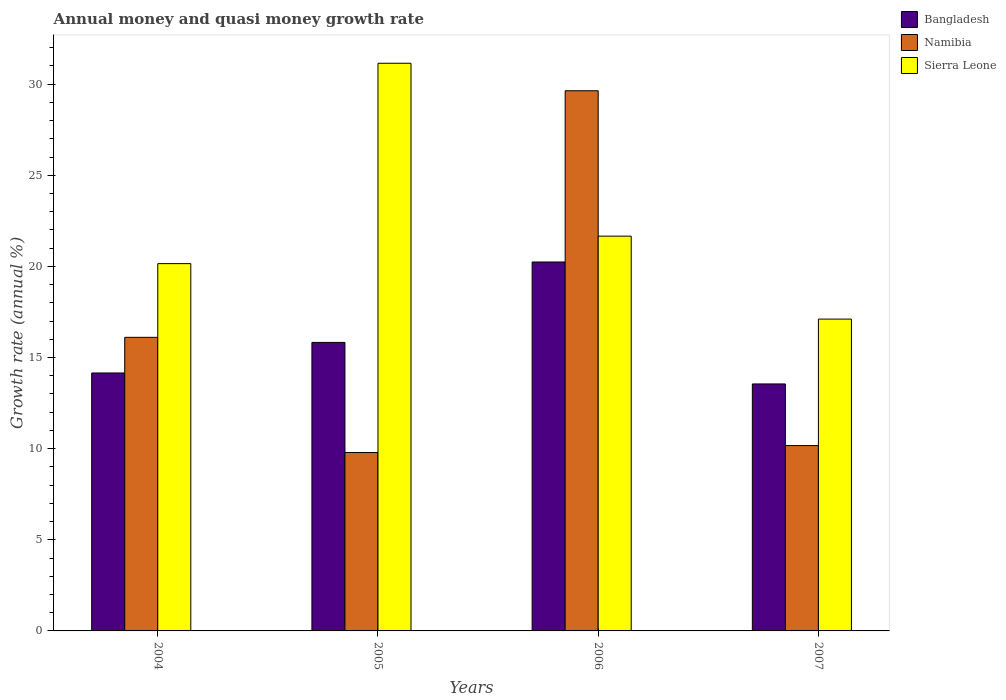What is the label of the 1st group of bars from the left?
Your answer should be very brief. 2004. In how many cases, is the number of bars for a given year not equal to the number of legend labels?
Your answer should be very brief. 0. What is the growth rate in Bangladesh in 2005?
Offer a terse response. 15.83. Across all years, what is the maximum growth rate in Bangladesh?
Your answer should be compact. 20.24. Across all years, what is the minimum growth rate in Sierra Leone?
Provide a succinct answer. 17.11. In which year was the growth rate in Bangladesh maximum?
Offer a terse response. 2006. What is the total growth rate in Bangladesh in the graph?
Offer a very short reply. 63.77. What is the difference between the growth rate in Namibia in 2004 and that in 2007?
Provide a short and direct response. 5.94. What is the difference between the growth rate in Sierra Leone in 2006 and the growth rate in Namibia in 2004?
Your answer should be very brief. 5.55. What is the average growth rate in Bangladesh per year?
Offer a very short reply. 15.94. In the year 2006, what is the difference between the growth rate in Bangladesh and growth rate in Namibia?
Offer a terse response. -9.4. What is the ratio of the growth rate in Namibia in 2005 to that in 2007?
Offer a very short reply. 0.96. Is the growth rate in Namibia in 2004 less than that in 2007?
Provide a short and direct response. No. Is the difference between the growth rate in Bangladesh in 2004 and 2006 greater than the difference between the growth rate in Namibia in 2004 and 2006?
Ensure brevity in your answer.  Yes. What is the difference between the highest and the second highest growth rate in Namibia?
Make the answer very short. 13.53. What is the difference between the highest and the lowest growth rate in Namibia?
Provide a short and direct response. 19.85. In how many years, is the growth rate in Sierra Leone greater than the average growth rate in Sierra Leone taken over all years?
Offer a very short reply. 1. Is the sum of the growth rate in Namibia in 2004 and 2005 greater than the maximum growth rate in Bangladesh across all years?
Offer a terse response. Yes. What does the 1st bar from the left in 2007 represents?
Offer a very short reply. Bangladesh. What does the 3rd bar from the right in 2006 represents?
Provide a short and direct response. Bangladesh. Is it the case that in every year, the sum of the growth rate in Bangladesh and growth rate in Namibia is greater than the growth rate in Sierra Leone?
Keep it short and to the point. No. How many bars are there?
Ensure brevity in your answer.  12. What is the difference between two consecutive major ticks on the Y-axis?
Offer a terse response. 5. Where does the legend appear in the graph?
Make the answer very short. Top right. How many legend labels are there?
Ensure brevity in your answer.  3. What is the title of the graph?
Offer a terse response. Annual money and quasi money growth rate. What is the label or title of the X-axis?
Offer a terse response. Years. What is the label or title of the Y-axis?
Offer a very short reply. Growth rate (annual %). What is the Growth rate (annual %) of Bangladesh in 2004?
Provide a short and direct response. 14.15. What is the Growth rate (annual %) in Namibia in 2004?
Your response must be concise. 16.11. What is the Growth rate (annual %) of Sierra Leone in 2004?
Make the answer very short. 20.15. What is the Growth rate (annual %) of Bangladesh in 2005?
Your response must be concise. 15.83. What is the Growth rate (annual %) in Namibia in 2005?
Provide a succinct answer. 9.79. What is the Growth rate (annual %) of Sierra Leone in 2005?
Your answer should be very brief. 31.15. What is the Growth rate (annual %) of Bangladesh in 2006?
Offer a terse response. 20.24. What is the Growth rate (annual %) of Namibia in 2006?
Offer a terse response. 29.64. What is the Growth rate (annual %) of Sierra Leone in 2006?
Your answer should be compact. 21.66. What is the Growth rate (annual %) in Bangladesh in 2007?
Your response must be concise. 13.55. What is the Growth rate (annual %) of Namibia in 2007?
Your answer should be very brief. 10.17. What is the Growth rate (annual %) in Sierra Leone in 2007?
Keep it short and to the point. 17.11. Across all years, what is the maximum Growth rate (annual %) of Bangladesh?
Your response must be concise. 20.24. Across all years, what is the maximum Growth rate (annual %) of Namibia?
Give a very brief answer. 29.64. Across all years, what is the maximum Growth rate (annual %) of Sierra Leone?
Make the answer very short. 31.15. Across all years, what is the minimum Growth rate (annual %) of Bangladesh?
Provide a short and direct response. 13.55. Across all years, what is the minimum Growth rate (annual %) of Namibia?
Your answer should be compact. 9.79. Across all years, what is the minimum Growth rate (annual %) of Sierra Leone?
Offer a terse response. 17.11. What is the total Growth rate (annual %) of Bangladesh in the graph?
Your answer should be very brief. 63.77. What is the total Growth rate (annual %) of Namibia in the graph?
Ensure brevity in your answer.  65.7. What is the total Growth rate (annual %) of Sierra Leone in the graph?
Your answer should be very brief. 90.07. What is the difference between the Growth rate (annual %) of Bangladesh in 2004 and that in 2005?
Provide a succinct answer. -1.68. What is the difference between the Growth rate (annual %) in Namibia in 2004 and that in 2005?
Offer a terse response. 6.32. What is the difference between the Growth rate (annual %) of Sierra Leone in 2004 and that in 2005?
Your answer should be compact. -10.99. What is the difference between the Growth rate (annual %) of Bangladesh in 2004 and that in 2006?
Keep it short and to the point. -6.09. What is the difference between the Growth rate (annual %) of Namibia in 2004 and that in 2006?
Your response must be concise. -13.53. What is the difference between the Growth rate (annual %) of Sierra Leone in 2004 and that in 2006?
Keep it short and to the point. -1.51. What is the difference between the Growth rate (annual %) in Bangladesh in 2004 and that in 2007?
Provide a succinct answer. 0.6. What is the difference between the Growth rate (annual %) in Namibia in 2004 and that in 2007?
Provide a short and direct response. 5.94. What is the difference between the Growth rate (annual %) in Sierra Leone in 2004 and that in 2007?
Ensure brevity in your answer.  3.04. What is the difference between the Growth rate (annual %) of Bangladesh in 2005 and that in 2006?
Keep it short and to the point. -4.41. What is the difference between the Growth rate (annual %) of Namibia in 2005 and that in 2006?
Make the answer very short. -19.85. What is the difference between the Growth rate (annual %) of Sierra Leone in 2005 and that in 2006?
Offer a very short reply. 9.48. What is the difference between the Growth rate (annual %) in Bangladesh in 2005 and that in 2007?
Ensure brevity in your answer.  2.28. What is the difference between the Growth rate (annual %) in Namibia in 2005 and that in 2007?
Make the answer very short. -0.38. What is the difference between the Growth rate (annual %) of Sierra Leone in 2005 and that in 2007?
Offer a very short reply. 14.04. What is the difference between the Growth rate (annual %) of Bangladesh in 2006 and that in 2007?
Offer a very short reply. 6.69. What is the difference between the Growth rate (annual %) of Namibia in 2006 and that in 2007?
Offer a terse response. 19.47. What is the difference between the Growth rate (annual %) in Sierra Leone in 2006 and that in 2007?
Give a very brief answer. 4.55. What is the difference between the Growth rate (annual %) in Bangladesh in 2004 and the Growth rate (annual %) in Namibia in 2005?
Your response must be concise. 4.36. What is the difference between the Growth rate (annual %) of Bangladesh in 2004 and the Growth rate (annual %) of Sierra Leone in 2005?
Offer a very short reply. -16.99. What is the difference between the Growth rate (annual %) in Namibia in 2004 and the Growth rate (annual %) in Sierra Leone in 2005?
Keep it short and to the point. -15.04. What is the difference between the Growth rate (annual %) in Bangladesh in 2004 and the Growth rate (annual %) in Namibia in 2006?
Offer a very short reply. -15.48. What is the difference between the Growth rate (annual %) of Bangladesh in 2004 and the Growth rate (annual %) of Sierra Leone in 2006?
Offer a terse response. -7.51. What is the difference between the Growth rate (annual %) in Namibia in 2004 and the Growth rate (annual %) in Sierra Leone in 2006?
Offer a terse response. -5.55. What is the difference between the Growth rate (annual %) of Bangladesh in 2004 and the Growth rate (annual %) of Namibia in 2007?
Your response must be concise. 3.98. What is the difference between the Growth rate (annual %) in Bangladesh in 2004 and the Growth rate (annual %) in Sierra Leone in 2007?
Make the answer very short. -2.96. What is the difference between the Growth rate (annual %) in Namibia in 2004 and the Growth rate (annual %) in Sierra Leone in 2007?
Your response must be concise. -1. What is the difference between the Growth rate (annual %) in Bangladesh in 2005 and the Growth rate (annual %) in Namibia in 2006?
Keep it short and to the point. -13.81. What is the difference between the Growth rate (annual %) of Bangladesh in 2005 and the Growth rate (annual %) of Sierra Leone in 2006?
Provide a short and direct response. -5.83. What is the difference between the Growth rate (annual %) in Namibia in 2005 and the Growth rate (annual %) in Sierra Leone in 2006?
Give a very brief answer. -11.87. What is the difference between the Growth rate (annual %) of Bangladesh in 2005 and the Growth rate (annual %) of Namibia in 2007?
Your answer should be compact. 5.66. What is the difference between the Growth rate (annual %) in Bangladesh in 2005 and the Growth rate (annual %) in Sierra Leone in 2007?
Offer a terse response. -1.28. What is the difference between the Growth rate (annual %) in Namibia in 2005 and the Growth rate (annual %) in Sierra Leone in 2007?
Your response must be concise. -7.32. What is the difference between the Growth rate (annual %) of Bangladesh in 2006 and the Growth rate (annual %) of Namibia in 2007?
Give a very brief answer. 10.07. What is the difference between the Growth rate (annual %) of Bangladesh in 2006 and the Growth rate (annual %) of Sierra Leone in 2007?
Provide a succinct answer. 3.13. What is the difference between the Growth rate (annual %) in Namibia in 2006 and the Growth rate (annual %) in Sierra Leone in 2007?
Ensure brevity in your answer.  12.53. What is the average Growth rate (annual %) in Bangladesh per year?
Offer a terse response. 15.94. What is the average Growth rate (annual %) of Namibia per year?
Your answer should be compact. 16.43. What is the average Growth rate (annual %) in Sierra Leone per year?
Provide a succinct answer. 22.52. In the year 2004, what is the difference between the Growth rate (annual %) in Bangladesh and Growth rate (annual %) in Namibia?
Your answer should be compact. -1.96. In the year 2004, what is the difference between the Growth rate (annual %) in Bangladesh and Growth rate (annual %) in Sierra Leone?
Ensure brevity in your answer.  -6. In the year 2004, what is the difference between the Growth rate (annual %) of Namibia and Growth rate (annual %) of Sierra Leone?
Keep it short and to the point. -4.04. In the year 2005, what is the difference between the Growth rate (annual %) in Bangladesh and Growth rate (annual %) in Namibia?
Your answer should be compact. 6.04. In the year 2005, what is the difference between the Growth rate (annual %) of Bangladesh and Growth rate (annual %) of Sierra Leone?
Your answer should be very brief. -15.32. In the year 2005, what is the difference between the Growth rate (annual %) of Namibia and Growth rate (annual %) of Sierra Leone?
Give a very brief answer. -21.36. In the year 2006, what is the difference between the Growth rate (annual %) of Bangladesh and Growth rate (annual %) of Namibia?
Keep it short and to the point. -9.4. In the year 2006, what is the difference between the Growth rate (annual %) in Bangladesh and Growth rate (annual %) in Sierra Leone?
Offer a very short reply. -1.42. In the year 2006, what is the difference between the Growth rate (annual %) in Namibia and Growth rate (annual %) in Sierra Leone?
Your answer should be compact. 7.98. In the year 2007, what is the difference between the Growth rate (annual %) in Bangladesh and Growth rate (annual %) in Namibia?
Offer a very short reply. 3.38. In the year 2007, what is the difference between the Growth rate (annual %) in Bangladesh and Growth rate (annual %) in Sierra Leone?
Offer a very short reply. -3.56. In the year 2007, what is the difference between the Growth rate (annual %) in Namibia and Growth rate (annual %) in Sierra Leone?
Your answer should be compact. -6.94. What is the ratio of the Growth rate (annual %) of Bangladesh in 2004 to that in 2005?
Offer a very short reply. 0.89. What is the ratio of the Growth rate (annual %) of Namibia in 2004 to that in 2005?
Your answer should be very brief. 1.65. What is the ratio of the Growth rate (annual %) in Sierra Leone in 2004 to that in 2005?
Offer a very short reply. 0.65. What is the ratio of the Growth rate (annual %) of Bangladesh in 2004 to that in 2006?
Provide a succinct answer. 0.7. What is the ratio of the Growth rate (annual %) of Namibia in 2004 to that in 2006?
Give a very brief answer. 0.54. What is the ratio of the Growth rate (annual %) of Sierra Leone in 2004 to that in 2006?
Keep it short and to the point. 0.93. What is the ratio of the Growth rate (annual %) in Bangladesh in 2004 to that in 2007?
Make the answer very short. 1.04. What is the ratio of the Growth rate (annual %) of Namibia in 2004 to that in 2007?
Your answer should be compact. 1.58. What is the ratio of the Growth rate (annual %) in Sierra Leone in 2004 to that in 2007?
Your answer should be compact. 1.18. What is the ratio of the Growth rate (annual %) of Bangladesh in 2005 to that in 2006?
Keep it short and to the point. 0.78. What is the ratio of the Growth rate (annual %) in Namibia in 2005 to that in 2006?
Give a very brief answer. 0.33. What is the ratio of the Growth rate (annual %) of Sierra Leone in 2005 to that in 2006?
Your answer should be very brief. 1.44. What is the ratio of the Growth rate (annual %) in Bangladesh in 2005 to that in 2007?
Your answer should be compact. 1.17. What is the ratio of the Growth rate (annual %) of Namibia in 2005 to that in 2007?
Your answer should be compact. 0.96. What is the ratio of the Growth rate (annual %) of Sierra Leone in 2005 to that in 2007?
Your answer should be very brief. 1.82. What is the ratio of the Growth rate (annual %) of Bangladesh in 2006 to that in 2007?
Your response must be concise. 1.49. What is the ratio of the Growth rate (annual %) of Namibia in 2006 to that in 2007?
Your response must be concise. 2.91. What is the ratio of the Growth rate (annual %) of Sierra Leone in 2006 to that in 2007?
Make the answer very short. 1.27. What is the difference between the highest and the second highest Growth rate (annual %) in Bangladesh?
Provide a short and direct response. 4.41. What is the difference between the highest and the second highest Growth rate (annual %) of Namibia?
Your response must be concise. 13.53. What is the difference between the highest and the second highest Growth rate (annual %) in Sierra Leone?
Your answer should be very brief. 9.48. What is the difference between the highest and the lowest Growth rate (annual %) of Bangladesh?
Provide a short and direct response. 6.69. What is the difference between the highest and the lowest Growth rate (annual %) in Namibia?
Provide a succinct answer. 19.85. What is the difference between the highest and the lowest Growth rate (annual %) in Sierra Leone?
Provide a succinct answer. 14.04. 